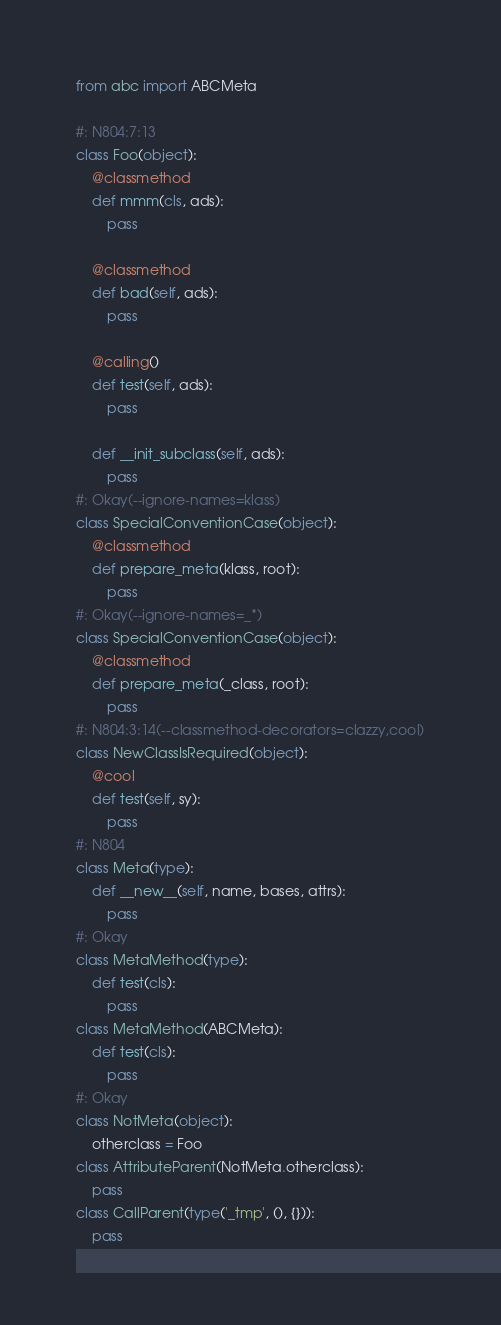<code> <loc_0><loc_0><loc_500><loc_500><_Python_>from abc import ABCMeta

#: N804:7:13
class Foo(object):
    @classmethod
    def mmm(cls, ads):
        pass

    @classmethod
    def bad(self, ads):
        pass

    @calling()
    def test(self, ads):
        pass

    def __init_subclass(self, ads):
        pass
#: Okay(--ignore-names=klass)
class SpecialConventionCase(object):
    @classmethod
    def prepare_meta(klass, root):
        pass
#: Okay(--ignore-names=_*)
class SpecialConventionCase(object):
    @classmethod
    def prepare_meta(_class, root):
        pass
#: N804:3:14(--classmethod-decorators=clazzy,cool)
class NewClassIsRequired(object):
    @cool
    def test(self, sy):
        pass
#: N804
class Meta(type):
    def __new__(self, name, bases, attrs):
        pass
#: Okay
class MetaMethod(type):
    def test(cls):
        pass
class MetaMethod(ABCMeta):
    def test(cls):
        pass
#: Okay
class NotMeta(object):
    otherclass = Foo
class AttributeParent(NotMeta.otherclass):
    pass
class CallParent(type('_tmp', (), {})):
    pass
</code> 